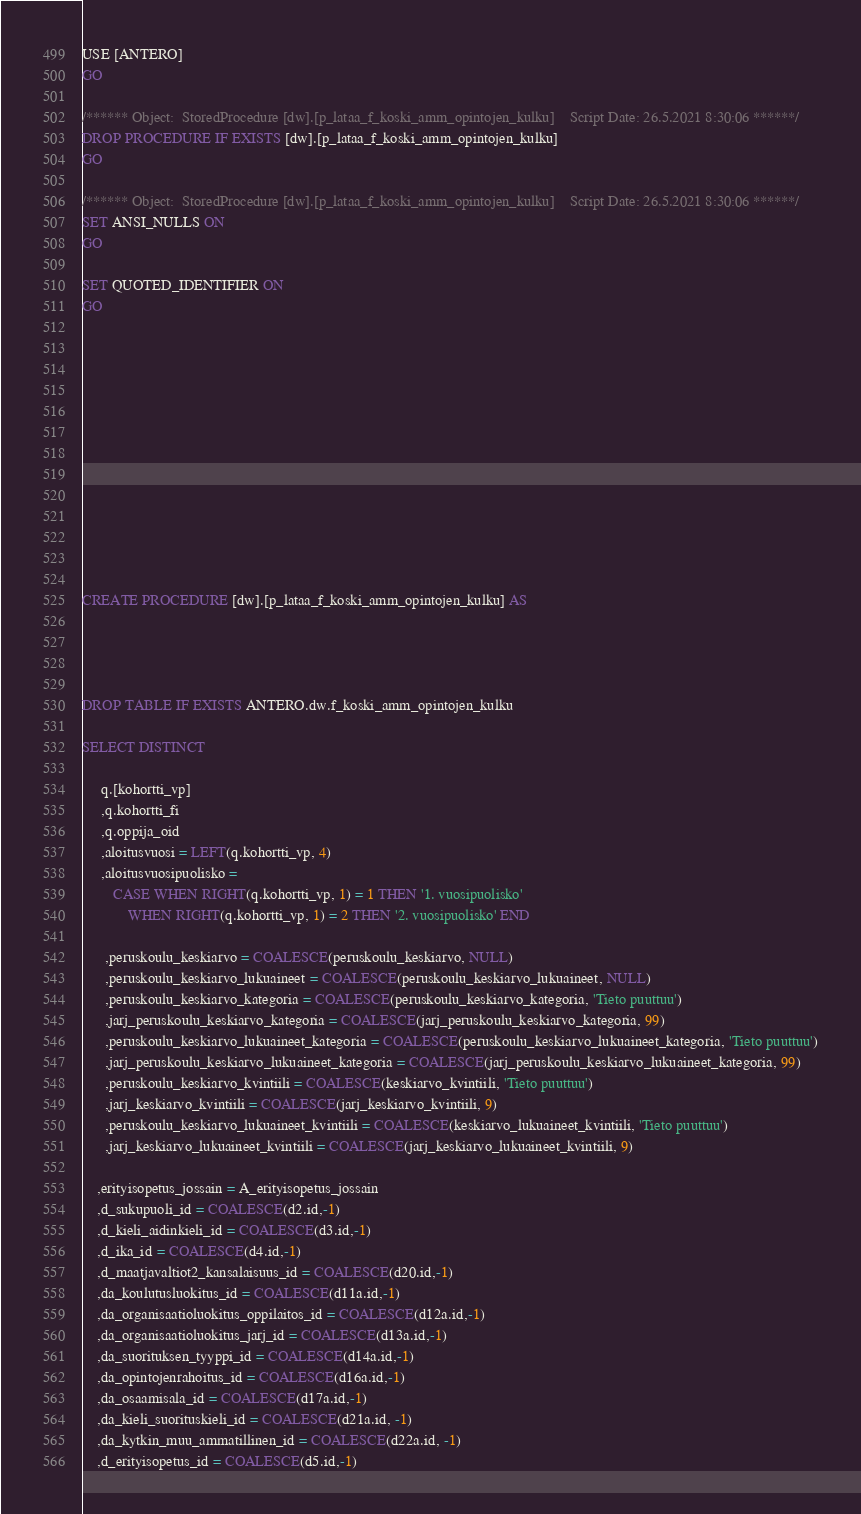<code> <loc_0><loc_0><loc_500><loc_500><_SQL_>USE [ANTERO]
GO

/****** Object:  StoredProcedure [dw].[p_lataa_f_koski_amm_opintojen_kulku]    Script Date: 26.5.2021 8:30:06 ******/
DROP PROCEDURE IF EXISTS [dw].[p_lataa_f_koski_amm_opintojen_kulku]
GO

/****** Object:  StoredProcedure [dw].[p_lataa_f_koski_amm_opintojen_kulku]    Script Date: 26.5.2021 8:30:06 ******/
SET ANSI_NULLS ON
GO

SET QUOTED_IDENTIFIER ON
GO













CREATE PROCEDURE [dw].[p_lataa_f_koski_amm_opintojen_kulku] AS




DROP TABLE IF EXISTS ANTERO.dw.f_koski_amm_opintojen_kulku

SELECT DISTINCT

     q.[kohortti_vp]
	 ,q.kohortti_fi
	 ,q.oppija_oid
	 ,aloitusvuosi = LEFT(q.kohortti_vp, 4)
	 ,aloitusvuosipuolisko = 
		CASE WHEN RIGHT(q.kohortti_vp, 1) = 1 THEN '1. vuosipuolisko'
			WHEN RIGHT(q.kohortti_vp, 1) = 2 THEN '2. vuosipuolisko' END

      ,peruskoulu_keskiarvo = COALESCE(peruskoulu_keskiarvo, NULL)
      ,peruskoulu_keskiarvo_lukuaineet = COALESCE(peruskoulu_keskiarvo_lukuaineet, NULL)
      ,peruskoulu_keskiarvo_kategoria = COALESCE(peruskoulu_keskiarvo_kategoria, 'Tieto puuttuu')
      ,jarj_peruskoulu_keskiarvo_kategoria = COALESCE(jarj_peruskoulu_keskiarvo_kategoria, 99)
      ,peruskoulu_keskiarvo_lukuaineet_kategoria = COALESCE(peruskoulu_keskiarvo_lukuaineet_kategoria, 'Tieto puuttuu')
      ,jarj_peruskoulu_keskiarvo_lukuaineet_kategoria = COALESCE(jarj_peruskoulu_keskiarvo_lukuaineet_kategoria, 99)
      ,peruskoulu_keskiarvo_kvintiili = COALESCE(keskiarvo_kvintiili, 'Tieto puuttuu')
      ,jarj_keskiarvo_kvintiili = COALESCE(jarj_keskiarvo_kvintiili, 9)
      ,peruskoulu_keskiarvo_lukuaineet_kvintiili = COALESCE(keskiarvo_lukuaineet_kvintiili, 'Tieto puuttuu')
      ,jarj_keskiarvo_lukuaineet_kvintiili = COALESCE(jarj_keskiarvo_lukuaineet_kvintiili, 9)

	,erityisopetus_jossain = A_erityisopetus_jossain
	,d_sukupuoli_id = COALESCE(d2.id,-1)
	,d_kieli_aidinkieli_id = COALESCE(d3.id,-1)
	,d_ika_id = COALESCE(d4.id,-1)
	,d_maatjavaltiot2_kansalaisuus_id = COALESCE(d20.id,-1)
	,da_koulutusluokitus_id = COALESCE(d11a.id,-1)
	,da_organisaatioluokitus_oppilaitos_id = COALESCE(d12a.id,-1)
	,da_organisaatioluokitus_jarj_id = COALESCE(d13a.id,-1)
	,da_suorituksen_tyyppi_id = COALESCE(d14a.id,-1)
	,da_opintojenrahoitus_id = COALESCE(d16a.id,-1)
	,da_osaamisala_id = COALESCE(d17a.id,-1)
	,da_kieli_suorituskieli_id = COALESCE(d21a.id, -1)
	,da_kytkin_muu_ammatillinen_id = COALESCE(d22a.id, -1)
	,d_erityisopetus_id = COALESCE(d5.id,-1)
</code> 